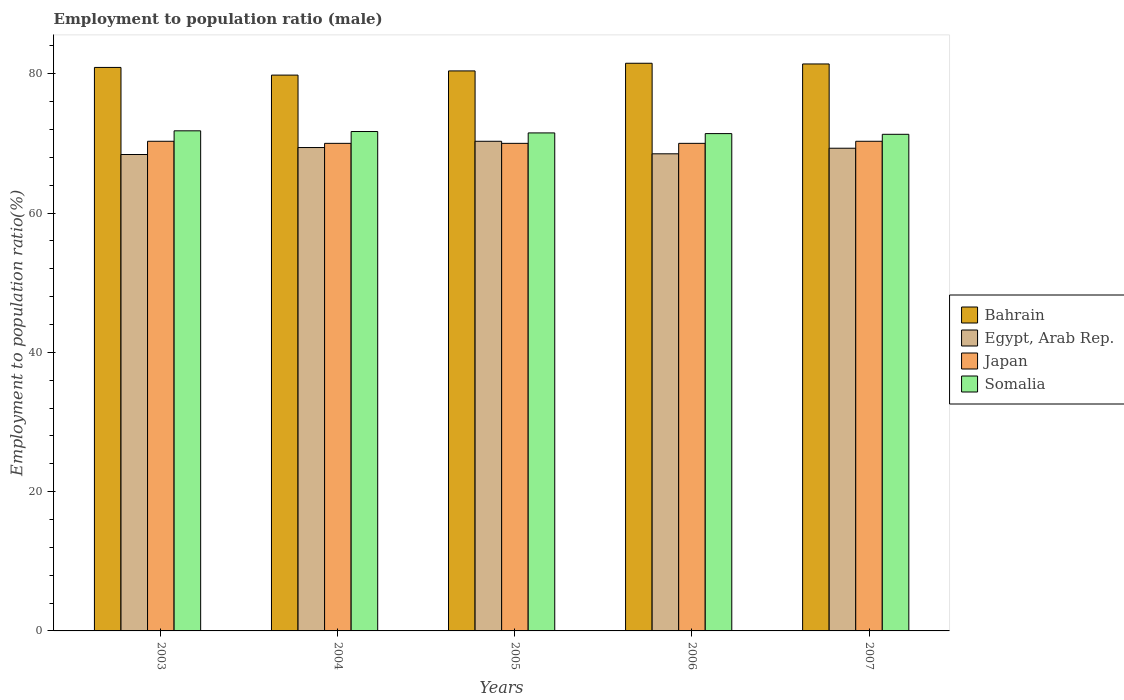Are the number of bars per tick equal to the number of legend labels?
Offer a terse response. Yes. Are the number of bars on each tick of the X-axis equal?
Offer a very short reply. Yes. What is the label of the 5th group of bars from the left?
Provide a succinct answer. 2007. What is the employment to population ratio in Egypt, Arab Rep. in 2004?
Your answer should be compact. 69.4. Across all years, what is the maximum employment to population ratio in Egypt, Arab Rep.?
Offer a very short reply. 70.3. Across all years, what is the minimum employment to population ratio in Egypt, Arab Rep.?
Give a very brief answer. 68.4. What is the total employment to population ratio in Japan in the graph?
Ensure brevity in your answer.  350.6. What is the difference between the employment to population ratio in Egypt, Arab Rep. in 2003 and that in 2004?
Ensure brevity in your answer.  -1. What is the difference between the employment to population ratio in Bahrain in 2007 and the employment to population ratio in Egypt, Arab Rep. in 2006?
Offer a terse response. 12.9. What is the average employment to population ratio in Somalia per year?
Provide a succinct answer. 71.54. In the year 2004, what is the difference between the employment to population ratio in Somalia and employment to population ratio in Bahrain?
Ensure brevity in your answer.  -8.1. What is the ratio of the employment to population ratio in Bahrain in 2004 to that in 2006?
Give a very brief answer. 0.98. What is the difference between the highest and the lowest employment to population ratio in Bahrain?
Offer a very short reply. 1.7. In how many years, is the employment to population ratio in Bahrain greater than the average employment to population ratio in Bahrain taken over all years?
Ensure brevity in your answer.  3. Is it the case that in every year, the sum of the employment to population ratio in Egypt, Arab Rep. and employment to population ratio in Somalia is greater than the sum of employment to population ratio in Japan and employment to population ratio in Bahrain?
Your answer should be compact. No. What does the 3rd bar from the left in 2006 represents?
Provide a short and direct response. Japan. What does the 4th bar from the right in 2007 represents?
Offer a terse response. Bahrain. How many bars are there?
Provide a succinct answer. 20. What is the difference between two consecutive major ticks on the Y-axis?
Your answer should be compact. 20. Does the graph contain grids?
Your answer should be compact. No. Where does the legend appear in the graph?
Offer a very short reply. Center right. How are the legend labels stacked?
Offer a very short reply. Vertical. What is the title of the graph?
Provide a short and direct response. Employment to population ratio (male). What is the Employment to population ratio(%) of Bahrain in 2003?
Your answer should be very brief. 80.9. What is the Employment to population ratio(%) in Egypt, Arab Rep. in 2003?
Offer a very short reply. 68.4. What is the Employment to population ratio(%) of Japan in 2003?
Give a very brief answer. 70.3. What is the Employment to population ratio(%) of Somalia in 2003?
Make the answer very short. 71.8. What is the Employment to population ratio(%) of Bahrain in 2004?
Your answer should be very brief. 79.8. What is the Employment to population ratio(%) of Egypt, Arab Rep. in 2004?
Offer a terse response. 69.4. What is the Employment to population ratio(%) of Somalia in 2004?
Give a very brief answer. 71.7. What is the Employment to population ratio(%) in Bahrain in 2005?
Ensure brevity in your answer.  80.4. What is the Employment to population ratio(%) in Egypt, Arab Rep. in 2005?
Provide a short and direct response. 70.3. What is the Employment to population ratio(%) in Japan in 2005?
Keep it short and to the point. 70. What is the Employment to population ratio(%) in Somalia in 2005?
Keep it short and to the point. 71.5. What is the Employment to population ratio(%) of Bahrain in 2006?
Your response must be concise. 81.5. What is the Employment to population ratio(%) in Egypt, Arab Rep. in 2006?
Make the answer very short. 68.5. What is the Employment to population ratio(%) of Japan in 2006?
Offer a very short reply. 70. What is the Employment to population ratio(%) of Somalia in 2006?
Keep it short and to the point. 71.4. What is the Employment to population ratio(%) in Bahrain in 2007?
Give a very brief answer. 81.4. What is the Employment to population ratio(%) of Egypt, Arab Rep. in 2007?
Your answer should be very brief. 69.3. What is the Employment to population ratio(%) in Japan in 2007?
Keep it short and to the point. 70.3. What is the Employment to population ratio(%) in Somalia in 2007?
Ensure brevity in your answer.  71.3. Across all years, what is the maximum Employment to population ratio(%) of Bahrain?
Keep it short and to the point. 81.5. Across all years, what is the maximum Employment to population ratio(%) in Egypt, Arab Rep.?
Provide a short and direct response. 70.3. Across all years, what is the maximum Employment to population ratio(%) of Japan?
Provide a succinct answer. 70.3. Across all years, what is the maximum Employment to population ratio(%) in Somalia?
Offer a terse response. 71.8. Across all years, what is the minimum Employment to population ratio(%) in Bahrain?
Provide a succinct answer. 79.8. Across all years, what is the minimum Employment to population ratio(%) in Egypt, Arab Rep.?
Your response must be concise. 68.4. Across all years, what is the minimum Employment to population ratio(%) in Japan?
Offer a very short reply. 70. Across all years, what is the minimum Employment to population ratio(%) in Somalia?
Keep it short and to the point. 71.3. What is the total Employment to population ratio(%) of Bahrain in the graph?
Offer a very short reply. 404. What is the total Employment to population ratio(%) of Egypt, Arab Rep. in the graph?
Ensure brevity in your answer.  345.9. What is the total Employment to population ratio(%) of Japan in the graph?
Offer a very short reply. 350.6. What is the total Employment to population ratio(%) of Somalia in the graph?
Ensure brevity in your answer.  357.7. What is the difference between the Employment to population ratio(%) of Egypt, Arab Rep. in 2003 and that in 2004?
Keep it short and to the point. -1. What is the difference between the Employment to population ratio(%) in Japan in 2003 and that in 2004?
Offer a terse response. 0.3. What is the difference between the Employment to population ratio(%) of Egypt, Arab Rep. in 2003 and that in 2005?
Your response must be concise. -1.9. What is the difference between the Employment to population ratio(%) of Somalia in 2003 and that in 2005?
Offer a terse response. 0.3. What is the difference between the Employment to population ratio(%) of Bahrain in 2003 and that in 2006?
Offer a very short reply. -0.6. What is the difference between the Employment to population ratio(%) in Japan in 2003 and that in 2006?
Provide a short and direct response. 0.3. What is the difference between the Employment to population ratio(%) of Somalia in 2003 and that in 2006?
Your response must be concise. 0.4. What is the difference between the Employment to population ratio(%) in Bahrain in 2003 and that in 2007?
Give a very brief answer. -0.5. What is the difference between the Employment to population ratio(%) of Bahrain in 2004 and that in 2005?
Your answer should be compact. -0.6. What is the difference between the Employment to population ratio(%) of Egypt, Arab Rep. in 2004 and that in 2005?
Offer a terse response. -0.9. What is the difference between the Employment to population ratio(%) of Egypt, Arab Rep. in 2004 and that in 2007?
Your answer should be compact. 0.1. What is the difference between the Employment to population ratio(%) in Somalia in 2004 and that in 2007?
Provide a succinct answer. 0.4. What is the difference between the Employment to population ratio(%) of Bahrain in 2005 and that in 2006?
Offer a terse response. -1.1. What is the difference between the Employment to population ratio(%) in Egypt, Arab Rep. in 2006 and that in 2007?
Provide a succinct answer. -0.8. What is the difference between the Employment to population ratio(%) of Japan in 2006 and that in 2007?
Your answer should be very brief. -0.3. What is the difference between the Employment to population ratio(%) in Bahrain in 2003 and the Employment to population ratio(%) in Japan in 2004?
Give a very brief answer. 10.9. What is the difference between the Employment to population ratio(%) of Bahrain in 2003 and the Employment to population ratio(%) of Somalia in 2004?
Your answer should be very brief. 9.2. What is the difference between the Employment to population ratio(%) of Egypt, Arab Rep. in 2003 and the Employment to population ratio(%) of Japan in 2004?
Keep it short and to the point. -1.6. What is the difference between the Employment to population ratio(%) of Japan in 2003 and the Employment to population ratio(%) of Somalia in 2004?
Provide a succinct answer. -1.4. What is the difference between the Employment to population ratio(%) in Bahrain in 2003 and the Employment to population ratio(%) in Egypt, Arab Rep. in 2005?
Your answer should be very brief. 10.6. What is the difference between the Employment to population ratio(%) of Bahrain in 2003 and the Employment to population ratio(%) of Egypt, Arab Rep. in 2006?
Give a very brief answer. 12.4. What is the difference between the Employment to population ratio(%) in Bahrain in 2003 and the Employment to population ratio(%) in Somalia in 2006?
Provide a short and direct response. 9.5. What is the difference between the Employment to population ratio(%) of Egypt, Arab Rep. in 2003 and the Employment to population ratio(%) of Japan in 2006?
Provide a succinct answer. -1.6. What is the difference between the Employment to population ratio(%) in Japan in 2003 and the Employment to population ratio(%) in Somalia in 2006?
Ensure brevity in your answer.  -1.1. What is the difference between the Employment to population ratio(%) in Bahrain in 2003 and the Employment to population ratio(%) in Egypt, Arab Rep. in 2007?
Provide a succinct answer. 11.6. What is the difference between the Employment to population ratio(%) in Egypt, Arab Rep. in 2003 and the Employment to population ratio(%) in Somalia in 2007?
Your answer should be very brief. -2.9. What is the difference between the Employment to population ratio(%) of Bahrain in 2004 and the Employment to population ratio(%) of Somalia in 2005?
Ensure brevity in your answer.  8.3. What is the difference between the Employment to population ratio(%) of Egypt, Arab Rep. in 2004 and the Employment to population ratio(%) of Japan in 2005?
Provide a short and direct response. -0.6. What is the difference between the Employment to population ratio(%) of Egypt, Arab Rep. in 2004 and the Employment to population ratio(%) of Somalia in 2005?
Provide a succinct answer. -2.1. What is the difference between the Employment to population ratio(%) of Bahrain in 2004 and the Employment to population ratio(%) of Japan in 2006?
Offer a very short reply. 9.8. What is the difference between the Employment to population ratio(%) in Bahrain in 2004 and the Employment to population ratio(%) in Somalia in 2006?
Keep it short and to the point. 8.4. What is the difference between the Employment to population ratio(%) of Egypt, Arab Rep. in 2004 and the Employment to population ratio(%) of Japan in 2006?
Your answer should be compact. -0.6. What is the difference between the Employment to population ratio(%) in Egypt, Arab Rep. in 2004 and the Employment to population ratio(%) in Somalia in 2006?
Ensure brevity in your answer.  -2. What is the difference between the Employment to population ratio(%) in Japan in 2004 and the Employment to population ratio(%) in Somalia in 2006?
Provide a short and direct response. -1.4. What is the difference between the Employment to population ratio(%) of Bahrain in 2004 and the Employment to population ratio(%) of Japan in 2007?
Your answer should be compact. 9.5. What is the difference between the Employment to population ratio(%) in Bahrain in 2005 and the Employment to population ratio(%) in Japan in 2006?
Your answer should be very brief. 10.4. What is the difference between the Employment to population ratio(%) of Bahrain in 2005 and the Employment to population ratio(%) of Somalia in 2006?
Your answer should be compact. 9. What is the difference between the Employment to population ratio(%) in Bahrain in 2005 and the Employment to population ratio(%) in Egypt, Arab Rep. in 2007?
Make the answer very short. 11.1. What is the difference between the Employment to population ratio(%) of Bahrain in 2005 and the Employment to population ratio(%) of Japan in 2007?
Offer a very short reply. 10.1. What is the difference between the Employment to population ratio(%) in Japan in 2005 and the Employment to population ratio(%) in Somalia in 2007?
Ensure brevity in your answer.  -1.3. What is the difference between the Employment to population ratio(%) in Bahrain in 2006 and the Employment to population ratio(%) in Egypt, Arab Rep. in 2007?
Your response must be concise. 12.2. What is the difference between the Employment to population ratio(%) of Japan in 2006 and the Employment to population ratio(%) of Somalia in 2007?
Your answer should be very brief. -1.3. What is the average Employment to population ratio(%) of Bahrain per year?
Provide a short and direct response. 80.8. What is the average Employment to population ratio(%) in Egypt, Arab Rep. per year?
Your answer should be very brief. 69.18. What is the average Employment to population ratio(%) of Japan per year?
Keep it short and to the point. 70.12. What is the average Employment to population ratio(%) in Somalia per year?
Offer a very short reply. 71.54. In the year 2003, what is the difference between the Employment to population ratio(%) in Bahrain and Employment to population ratio(%) in Japan?
Offer a very short reply. 10.6. In the year 2004, what is the difference between the Employment to population ratio(%) in Bahrain and Employment to population ratio(%) in Egypt, Arab Rep.?
Offer a terse response. 10.4. In the year 2004, what is the difference between the Employment to population ratio(%) in Bahrain and Employment to population ratio(%) in Somalia?
Make the answer very short. 8.1. In the year 2004, what is the difference between the Employment to population ratio(%) in Egypt, Arab Rep. and Employment to population ratio(%) in Japan?
Give a very brief answer. -0.6. In the year 2005, what is the difference between the Employment to population ratio(%) of Bahrain and Employment to population ratio(%) of Egypt, Arab Rep.?
Your answer should be very brief. 10.1. In the year 2005, what is the difference between the Employment to population ratio(%) of Bahrain and Employment to population ratio(%) of Somalia?
Offer a terse response. 8.9. In the year 2005, what is the difference between the Employment to population ratio(%) in Japan and Employment to population ratio(%) in Somalia?
Your answer should be very brief. -1.5. In the year 2006, what is the difference between the Employment to population ratio(%) of Bahrain and Employment to population ratio(%) of Egypt, Arab Rep.?
Provide a short and direct response. 13. In the year 2006, what is the difference between the Employment to population ratio(%) of Bahrain and Employment to population ratio(%) of Japan?
Your response must be concise. 11.5. In the year 2006, what is the difference between the Employment to population ratio(%) of Bahrain and Employment to population ratio(%) of Somalia?
Ensure brevity in your answer.  10.1. In the year 2006, what is the difference between the Employment to population ratio(%) in Egypt, Arab Rep. and Employment to population ratio(%) in Somalia?
Provide a short and direct response. -2.9. In the year 2006, what is the difference between the Employment to population ratio(%) of Japan and Employment to population ratio(%) of Somalia?
Your response must be concise. -1.4. In the year 2007, what is the difference between the Employment to population ratio(%) of Bahrain and Employment to population ratio(%) of Japan?
Keep it short and to the point. 11.1. In the year 2007, what is the difference between the Employment to population ratio(%) in Egypt, Arab Rep. and Employment to population ratio(%) in Somalia?
Your answer should be compact. -2. What is the ratio of the Employment to population ratio(%) in Bahrain in 2003 to that in 2004?
Your response must be concise. 1.01. What is the ratio of the Employment to population ratio(%) in Egypt, Arab Rep. in 2003 to that in 2004?
Your response must be concise. 0.99. What is the ratio of the Employment to population ratio(%) in Japan in 2003 to that in 2004?
Offer a terse response. 1. What is the ratio of the Employment to population ratio(%) in Bahrain in 2003 to that in 2005?
Your answer should be very brief. 1.01. What is the ratio of the Employment to population ratio(%) of Egypt, Arab Rep. in 2003 to that in 2005?
Your answer should be compact. 0.97. What is the ratio of the Employment to population ratio(%) in Japan in 2003 to that in 2005?
Your answer should be compact. 1. What is the ratio of the Employment to population ratio(%) of Somalia in 2003 to that in 2005?
Keep it short and to the point. 1. What is the ratio of the Employment to population ratio(%) of Bahrain in 2003 to that in 2006?
Offer a terse response. 0.99. What is the ratio of the Employment to population ratio(%) in Japan in 2003 to that in 2006?
Give a very brief answer. 1. What is the ratio of the Employment to population ratio(%) in Somalia in 2003 to that in 2006?
Provide a succinct answer. 1.01. What is the ratio of the Employment to population ratio(%) in Egypt, Arab Rep. in 2003 to that in 2007?
Make the answer very short. 0.99. What is the ratio of the Employment to population ratio(%) in Somalia in 2003 to that in 2007?
Keep it short and to the point. 1.01. What is the ratio of the Employment to population ratio(%) of Bahrain in 2004 to that in 2005?
Give a very brief answer. 0.99. What is the ratio of the Employment to population ratio(%) of Egypt, Arab Rep. in 2004 to that in 2005?
Your answer should be very brief. 0.99. What is the ratio of the Employment to population ratio(%) of Somalia in 2004 to that in 2005?
Your response must be concise. 1. What is the ratio of the Employment to population ratio(%) of Bahrain in 2004 to that in 2006?
Make the answer very short. 0.98. What is the ratio of the Employment to population ratio(%) in Egypt, Arab Rep. in 2004 to that in 2006?
Your response must be concise. 1.01. What is the ratio of the Employment to population ratio(%) of Japan in 2004 to that in 2006?
Your answer should be very brief. 1. What is the ratio of the Employment to population ratio(%) in Bahrain in 2004 to that in 2007?
Give a very brief answer. 0.98. What is the ratio of the Employment to population ratio(%) in Japan in 2004 to that in 2007?
Keep it short and to the point. 1. What is the ratio of the Employment to population ratio(%) in Somalia in 2004 to that in 2007?
Provide a short and direct response. 1.01. What is the ratio of the Employment to population ratio(%) in Bahrain in 2005 to that in 2006?
Make the answer very short. 0.99. What is the ratio of the Employment to population ratio(%) in Egypt, Arab Rep. in 2005 to that in 2006?
Your response must be concise. 1.03. What is the ratio of the Employment to population ratio(%) of Japan in 2005 to that in 2006?
Keep it short and to the point. 1. What is the ratio of the Employment to population ratio(%) in Egypt, Arab Rep. in 2005 to that in 2007?
Keep it short and to the point. 1.01. What is the ratio of the Employment to population ratio(%) in Bahrain in 2006 to that in 2007?
Offer a very short reply. 1. What is the ratio of the Employment to population ratio(%) of Egypt, Arab Rep. in 2006 to that in 2007?
Ensure brevity in your answer.  0.99. What is the ratio of the Employment to population ratio(%) of Somalia in 2006 to that in 2007?
Provide a succinct answer. 1. What is the difference between the highest and the second highest Employment to population ratio(%) in Egypt, Arab Rep.?
Your response must be concise. 0.9. What is the difference between the highest and the lowest Employment to population ratio(%) of Bahrain?
Your answer should be compact. 1.7. What is the difference between the highest and the lowest Employment to population ratio(%) of Egypt, Arab Rep.?
Ensure brevity in your answer.  1.9. What is the difference between the highest and the lowest Employment to population ratio(%) in Japan?
Provide a short and direct response. 0.3. 